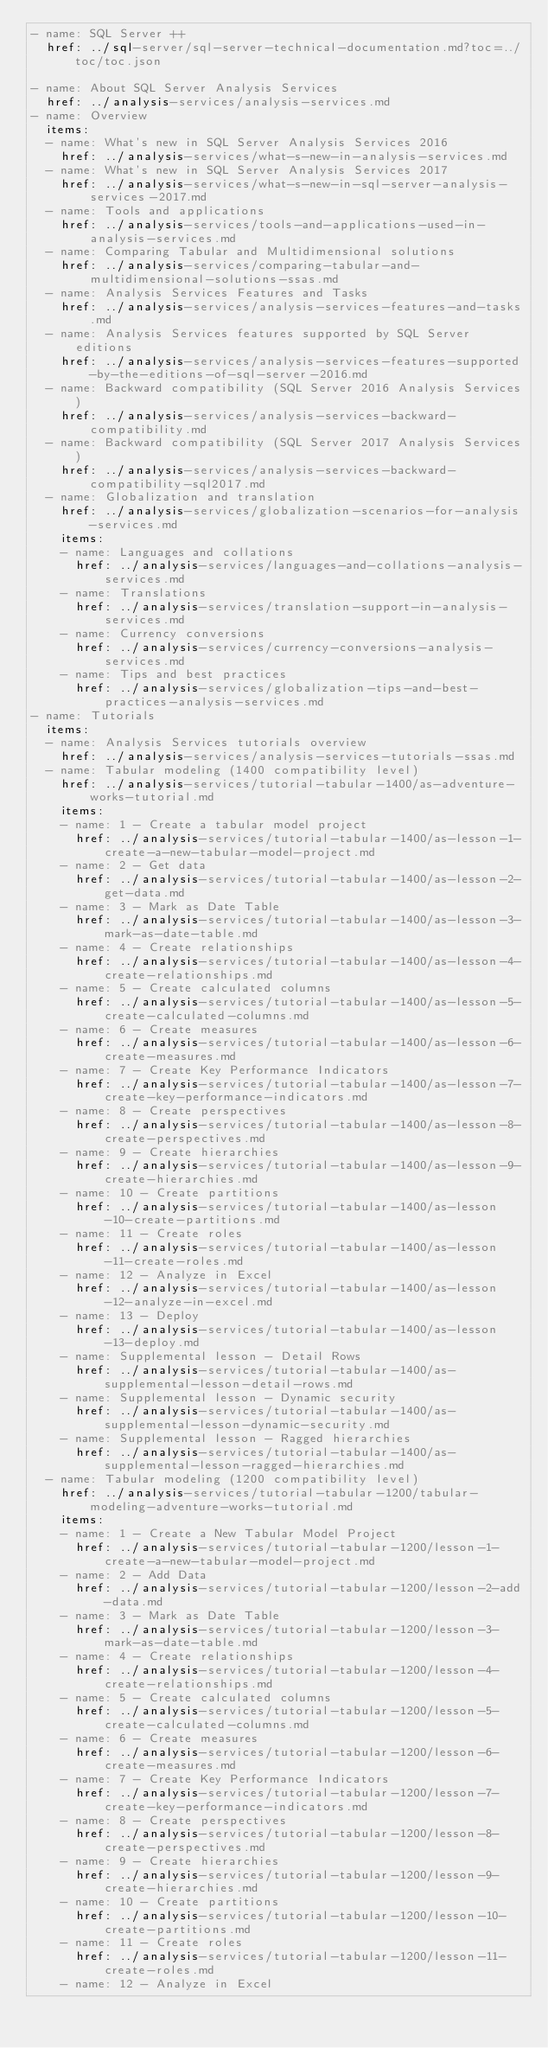<code> <loc_0><loc_0><loc_500><loc_500><_YAML_>- name: SQL Server ++
  href: ../sql-server/sql-server-technical-documentation.md?toc=../toc/toc.json

- name: About SQL Server Analysis Services
  href: ../analysis-services/analysis-services.md
- name: Overview
  items:
  - name: What's new in SQL Server Analysis Services 2016
    href: ../analysis-services/what-s-new-in-analysis-services.md
  - name: What's new in SQL Server Analysis Services 2017
    href: ../analysis-services/what-s-new-in-sql-server-analysis-services-2017.md
  - name: Tools and applications
    href: ../analysis-services/tools-and-applications-used-in-analysis-services.md
  - name: Comparing Tabular and Multidimensional solutions
    href: ../analysis-services/comparing-tabular-and-multidimensional-solutions-ssas.md
  - name: Analysis Services Features and Tasks
    href: ../analysis-services/analysis-services-features-and-tasks.md
  - name: Analysis Services features supported by SQL Server editions
    href: ../analysis-services/analysis-services-features-supported-by-the-editions-of-sql-server-2016.md
  - name: Backward compatibility (SQL Server 2016 Analysis Services)
    href: ../analysis-services/analysis-services-backward-compatibility.md
  - name: Backward compatibility (SQL Server 2017 Analysis Services)
    href: ../analysis-services/analysis-services-backward-compatibility-sql2017.md
  - name: Globalization and translation
    href: ../analysis-services/globalization-scenarios-for-analysis-services.md
    items:
    - name: Languages and collations
      href: ../analysis-services/languages-and-collations-analysis-services.md
    - name: Translations
      href: ../analysis-services/translation-support-in-analysis-services.md
    - name: Currency conversions
      href: ../analysis-services/currency-conversions-analysis-services.md
    - name: Tips and best practices
      href: ../analysis-services/globalization-tips-and-best-practices-analysis-services.md
- name: Tutorials
  items:
  - name: Analysis Services tutorials overview
    href: ../analysis-services/analysis-services-tutorials-ssas.md
  - name: Tabular modeling (1400 compatibility level)
    href: ../analysis-services/tutorial-tabular-1400/as-adventure-works-tutorial.md
    items:
    - name: 1 - Create a tabular model project
      href: ../analysis-services/tutorial-tabular-1400/as-lesson-1-create-a-new-tabular-model-project.md
    - name: 2 - Get data
      href: ../analysis-services/tutorial-tabular-1400/as-lesson-2-get-data.md
    - name: 3 - Mark as Date Table
      href: ../analysis-services/tutorial-tabular-1400/as-lesson-3-mark-as-date-table.md
    - name: 4 - Create relationships
      href: ../analysis-services/tutorial-tabular-1400/as-lesson-4-create-relationships.md
    - name: 5 - Create calculated columns
      href: ../analysis-services/tutorial-tabular-1400/as-lesson-5-create-calculated-columns.md
    - name: 6 - Create measures
      href: ../analysis-services/tutorial-tabular-1400/as-lesson-6-create-measures.md
    - name: 7 - Create Key Performance Indicators
      href: ../analysis-services/tutorial-tabular-1400/as-lesson-7-create-key-performance-indicators.md
    - name: 8 - Create perspectives
      href: ../analysis-services/tutorial-tabular-1400/as-lesson-8-create-perspectives.md
    - name: 9 - Create hierarchies
      href: ../analysis-services/tutorial-tabular-1400/as-lesson-9-create-hierarchies.md
    - name: 10 - Create partitions
      href: ../analysis-services/tutorial-tabular-1400/as-lesson-10-create-partitions.md
    - name: 11 - Create roles
      href: ../analysis-services/tutorial-tabular-1400/as-lesson-11-create-roles.md
    - name: 12 - Analyze in Excel
      href: ../analysis-services/tutorial-tabular-1400/as-lesson-12-analyze-in-excel.md
    - name: 13 - Deploy
      href: ../analysis-services/tutorial-tabular-1400/as-lesson-13-deploy.md
    - name: Supplemental lesson - Detail Rows
      href: ../analysis-services/tutorial-tabular-1400/as-supplemental-lesson-detail-rows.md
    - name: Supplemental lesson - Dynamic security
      href: ../analysis-services/tutorial-tabular-1400/as-supplemental-lesson-dynamic-security.md
    - name: Supplemental lesson - Ragged hierarchies
      href: ../analysis-services/tutorial-tabular-1400/as-supplemental-lesson-ragged-hierarchies.md
  - name: Tabular modeling (1200 compatibility level)
    href: ../analysis-services/tutorial-tabular-1200/tabular-modeling-adventure-works-tutorial.md
    items:
    - name: 1 - Create a New Tabular Model Project
      href: ../analysis-services/tutorial-tabular-1200/lesson-1-create-a-new-tabular-model-project.md
    - name: 2 - Add Data
      href: ../analysis-services/tutorial-tabular-1200/lesson-2-add-data.md
    - name: 3 - Mark as Date Table
      href: ../analysis-services/tutorial-tabular-1200/lesson-3-mark-as-date-table.md
    - name: 4 - Create relationships
      href: ../analysis-services/tutorial-tabular-1200/lesson-4-create-relationships.md
    - name: 5 - Create calculated columns
      href: ../analysis-services/tutorial-tabular-1200/lesson-5-create-calculated-columns.md
    - name: 6 - Create measures
      href: ../analysis-services/tutorial-tabular-1200/lesson-6-create-measures.md
    - name: 7 - Create Key Performance Indicators
      href: ../analysis-services/tutorial-tabular-1200/lesson-7-create-key-performance-indicators.md
    - name: 8 - Create perspectives
      href: ../analysis-services/tutorial-tabular-1200/lesson-8-create-perspectives.md
    - name: 9 - Create hierarchies
      href: ../analysis-services/tutorial-tabular-1200/lesson-9-create-hierarchies.md
    - name: 10 - Create partitions
      href: ../analysis-services/tutorial-tabular-1200/lesson-10-create-partitions.md
    - name: 11 - Create roles
      href: ../analysis-services/tutorial-tabular-1200/lesson-11-create-roles.md
    - name: 12 - Analyze in Excel</code> 